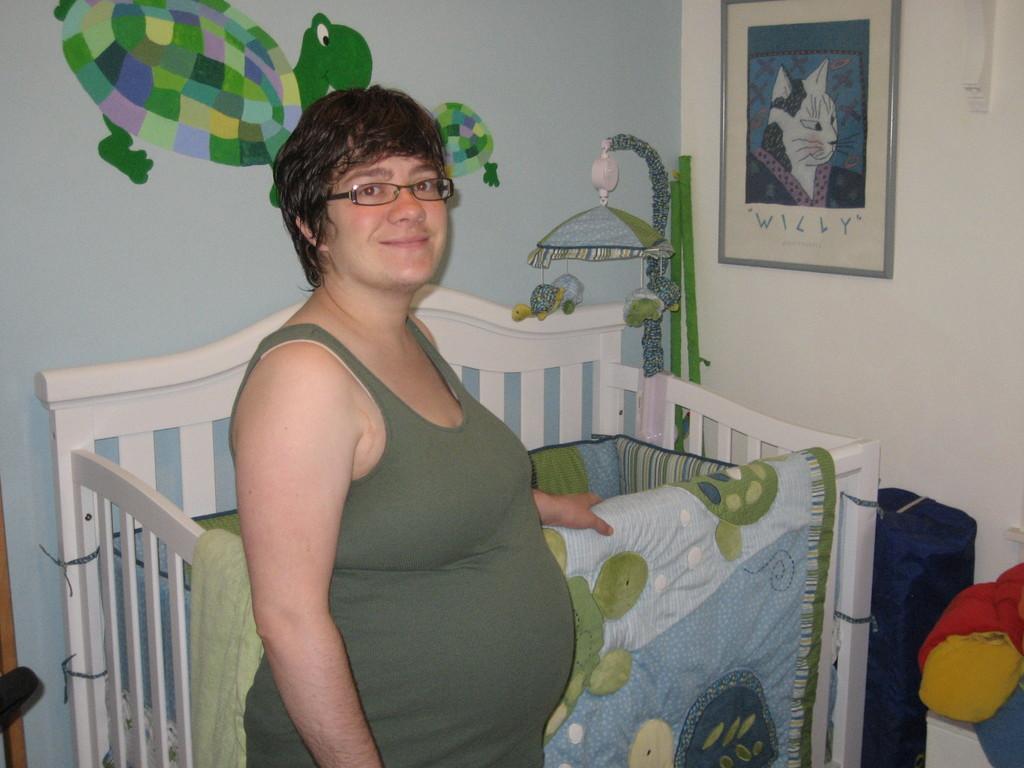Can you describe this image briefly? In the foreground of the picture there is a woman, a child bed. On right there are toys. In the background we can see frame and poster to the wall. 